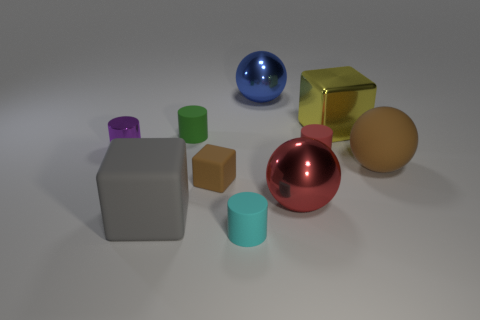What number of brown rubber balls have the same size as the red sphere?
Keep it short and to the point. 1. There is a matte block that is the same color as the matte ball; what is its size?
Your answer should be very brief. Small. There is a big rubber object that is on the left side of the brown thing on the right side of the large yellow cube; what is its color?
Provide a short and direct response. Gray. Is there a matte block of the same color as the big matte sphere?
Offer a very short reply. Yes. There is a rubber cube that is the same size as the brown sphere; what color is it?
Give a very brief answer. Gray. Is the material of the small cyan thing in front of the small purple metal object the same as the red sphere?
Your answer should be very brief. No. Are there any small red matte things that are left of the matte cube on the left side of the matte cube behind the large gray object?
Offer a terse response. No. There is a rubber object that is in front of the big gray matte object; is it the same shape as the small green rubber thing?
Ensure brevity in your answer.  Yes. There is a shiny object that is to the left of the sphere that is behind the red cylinder; what shape is it?
Offer a very short reply. Cylinder. There is a brown object to the right of the small cylinder in front of the large matte object that is left of the green cylinder; what is its size?
Provide a short and direct response. Large. 